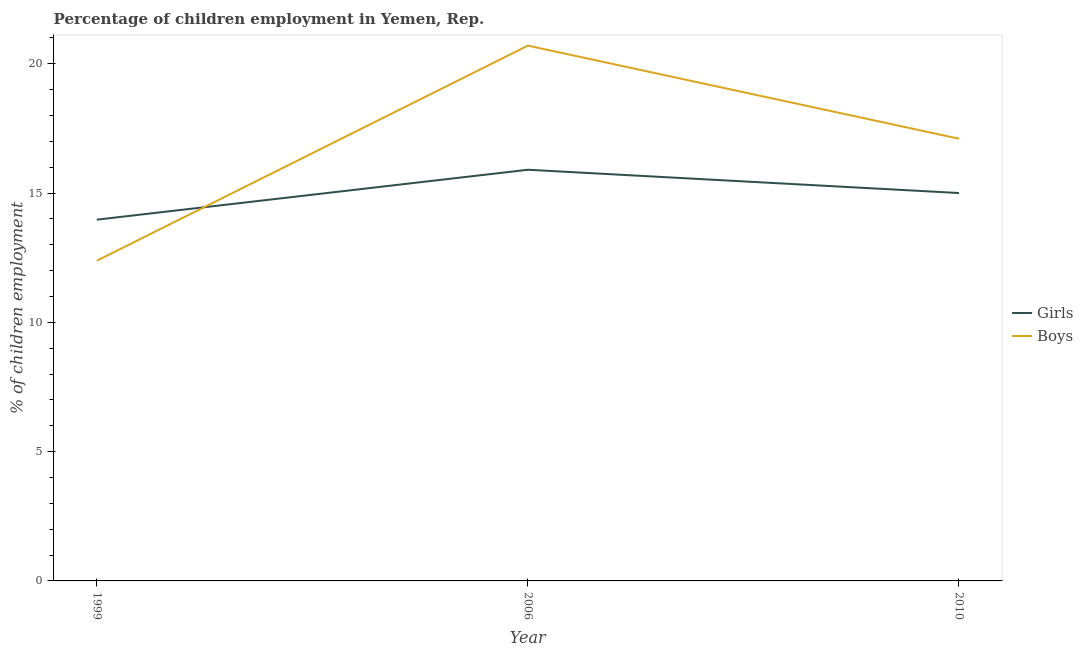Is the number of lines equal to the number of legend labels?
Provide a succinct answer. Yes. What is the percentage of employed boys in 2010?
Offer a terse response. 17.1. Across all years, what is the maximum percentage of employed boys?
Make the answer very short. 20.7. Across all years, what is the minimum percentage of employed girls?
Offer a terse response. 13.97. In which year was the percentage of employed girls maximum?
Keep it short and to the point. 2006. What is the total percentage of employed girls in the graph?
Offer a terse response. 44.87. What is the difference between the percentage of employed girls in 2006 and that in 2010?
Your answer should be compact. 0.9. What is the difference between the percentage of employed girls in 2006 and the percentage of employed boys in 2010?
Make the answer very short. -1.2. What is the average percentage of employed boys per year?
Your answer should be compact. 16.73. In the year 1999, what is the difference between the percentage of employed boys and percentage of employed girls?
Your response must be concise. -1.59. What is the ratio of the percentage of employed girls in 1999 to that in 2010?
Your answer should be compact. 0.93. What is the difference between the highest and the second highest percentage of employed girls?
Your answer should be compact. 0.9. What is the difference between the highest and the lowest percentage of employed girls?
Provide a succinct answer. 1.93. Is the percentage of employed girls strictly greater than the percentage of employed boys over the years?
Give a very brief answer. No. Is the percentage of employed boys strictly less than the percentage of employed girls over the years?
Keep it short and to the point. No. How many years are there in the graph?
Give a very brief answer. 3. What is the difference between two consecutive major ticks on the Y-axis?
Your response must be concise. 5. Are the values on the major ticks of Y-axis written in scientific E-notation?
Make the answer very short. No. Where does the legend appear in the graph?
Offer a terse response. Center right. How many legend labels are there?
Your answer should be very brief. 2. How are the legend labels stacked?
Your response must be concise. Vertical. What is the title of the graph?
Provide a succinct answer. Percentage of children employment in Yemen, Rep. What is the label or title of the Y-axis?
Keep it short and to the point. % of children employment. What is the % of children employment in Girls in 1999?
Provide a succinct answer. 13.97. What is the % of children employment in Boys in 1999?
Your answer should be compact. 12.38. What is the % of children employment in Girls in 2006?
Your answer should be compact. 15.9. What is the % of children employment in Boys in 2006?
Make the answer very short. 20.7. What is the % of children employment in Girls in 2010?
Make the answer very short. 15. What is the % of children employment of Boys in 2010?
Keep it short and to the point. 17.1. Across all years, what is the maximum % of children employment in Boys?
Offer a terse response. 20.7. Across all years, what is the minimum % of children employment of Girls?
Give a very brief answer. 13.97. Across all years, what is the minimum % of children employment of Boys?
Your answer should be very brief. 12.38. What is the total % of children employment in Girls in the graph?
Offer a very short reply. 44.87. What is the total % of children employment in Boys in the graph?
Provide a succinct answer. 50.18. What is the difference between the % of children employment in Girls in 1999 and that in 2006?
Keep it short and to the point. -1.93. What is the difference between the % of children employment of Boys in 1999 and that in 2006?
Provide a short and direct response. -8.32. What is the difference between the % of children employment in Girls in 1999 and that in 2010?
Provide a succinct answer. -1.03. What is the difference between the % of children employment of Boys in 1999 and that in 2010?
Provide a succinct answer. -4.72. What is the difference between the % of children employment in Boys in 2006 and that in 2010?
Ensure brevity in your answer.  3.6. What is the difference between the % of children employment in Girls in 1999 and the % of children employment in Boys in 2006?
Offer a very short reply. -6.73. What is the difference between the % of children employment of Girls in 1999 and the % of children employment of Boys in 2010?
Ensure brevity in your answer.  -3.13. What is the average % of children employment of Girls per year?
Make the answer very short. 14.96. What is the average % of children employment of Boys per year?
Your answer should be very brief. 16.73. In the year 1999, what is the difference between the % of children employment of Girls and % of children employment of Boys?
Make the answer very short. 1.59. What is the ratio of the % of children employment of Girls in 1999 to that in 2006?
Offer a terse response. 0.88. What is the ratio of the % of children employment in Boys in 1999 to that in 2006?
Your answer should be very brief. 0.6. What is the ratio of the % of children employment in Girls in 1999 to that in 2010?
Keep it short and to the point. 0.93. What is the ratio of the % of children employment in Boys in 1999 to that in 2010?
Offer a very short reply. 0.72. What is the ratio of the % of children employment in Girls in 2006 to that in 2010?
Your answer should be very brief. 1.06. What is the ratio of the % of children employment in Boys in 2006 to that in 2010?
Keep it short and to the point. 1.21. What is the difference between the highest and the second highest % of children employment in Girls?
Give a very brief answer. 0.9. What is the difference between the highest and the lowest % of children employment in Girls?
Your answer should be very brief. 1.93. What is the difference between the highest and the lowest % of children employment in Boys?
Give a very brief answer. 8.32. 